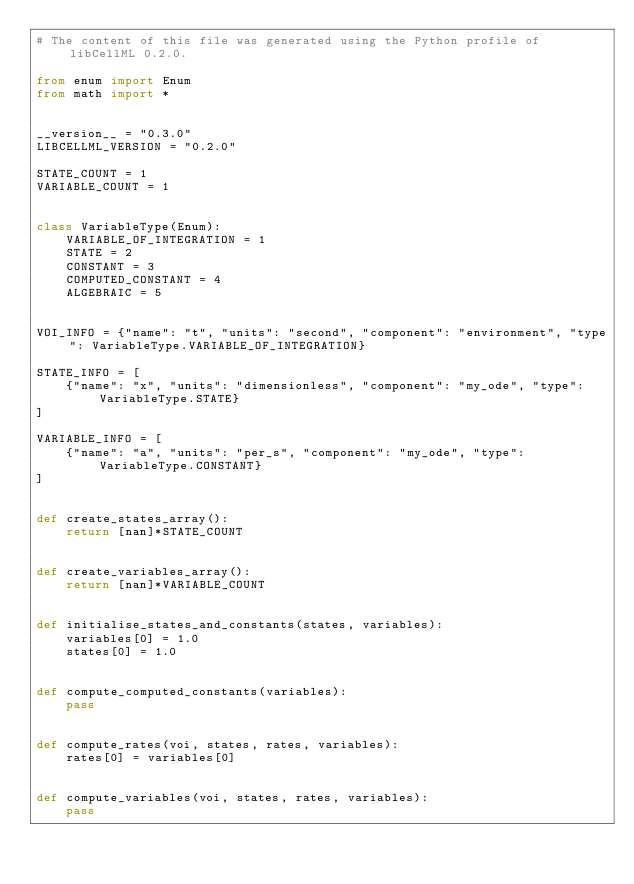Convert code to text. <code><loc_0><loc_0><loc_500><loc_500><_Python_># The content of this file was generated using the Python profile of libCellML 0.2.0.

from enum import Enum
from math import *


__version__ = "0.3.0"
LIBCELLML_VERSION = "0.2.0"

STATE_COUNT = 1
VARIABLE_COUNT = 1


class VariableType(Enum):
    VARIABLE_OF_INTEGRATION = 1
    STATE = 2
    CONSTANT = 3
    COMPUTED_CONSTANT = 4
    ALGEBRAIC = 5


VOI_INFO = {"name": "t", "units": "second", "component": "environment", "type": VariableType.VARIABLE_OF_INTEGRATION}

STATE_INFO = [
    {"name": "x", "units": "dimensionless", "component": "my_ode", "type": VariableType.STATE}
]

VARIABLE_INFO = [
    {"name": "a", "units": "per_s", "component": "my_ode", "type": VariableType.CONSTANT}
]


def create_states_array():
    return [nan]*STATE_COUNT


def create_variables_array():
    return [nan]*VARIABLE_COUNT


def initialise_states_and_constants(states, variables):
    variables[0] = 1.0
    states[0] = 1.0


def compute_computed_constants(variables):
    pass


def compute_rates(voi, states, rates, variables):
    rates[0] = variables[0]


def compute_variables(voi, states, rates, variables):
    pass
</code> 